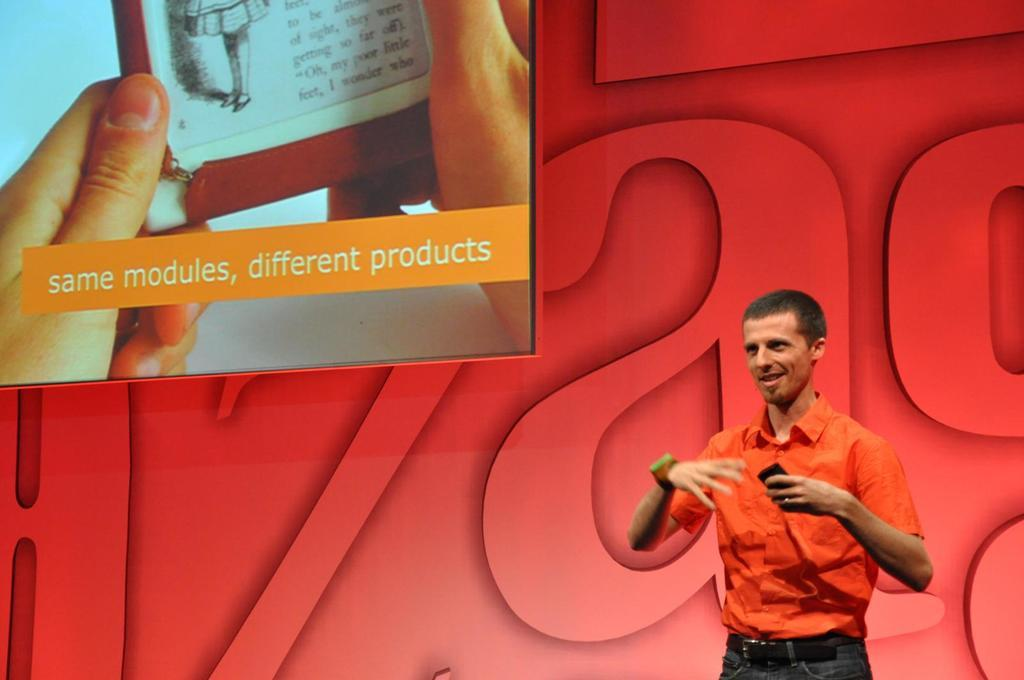<image>
Provide a brief description of the given image. Man in an orange shirt with a photo about the same modules just a different product. 